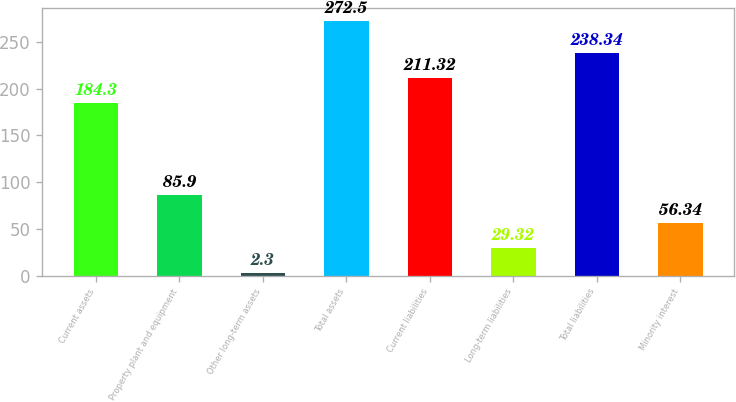<chart> <loc_0><loc_0><loc_500><loc_500><bar_chart><fcel>Current assets<fcel>Property plant and equipment<fcel>Other long-term assets<fcel>Total assets<fcel>Current liabilities<fcel>Long-term liabilities<fcel>Total liabilities<fcel>Minority interest<nl><fcel>184.3<fcel>85.9<fcel>2.3<fcel>272.5<fcel>211.32<fcel>29.32<fcel>238.34<fcel>56.34<nl></chart> 